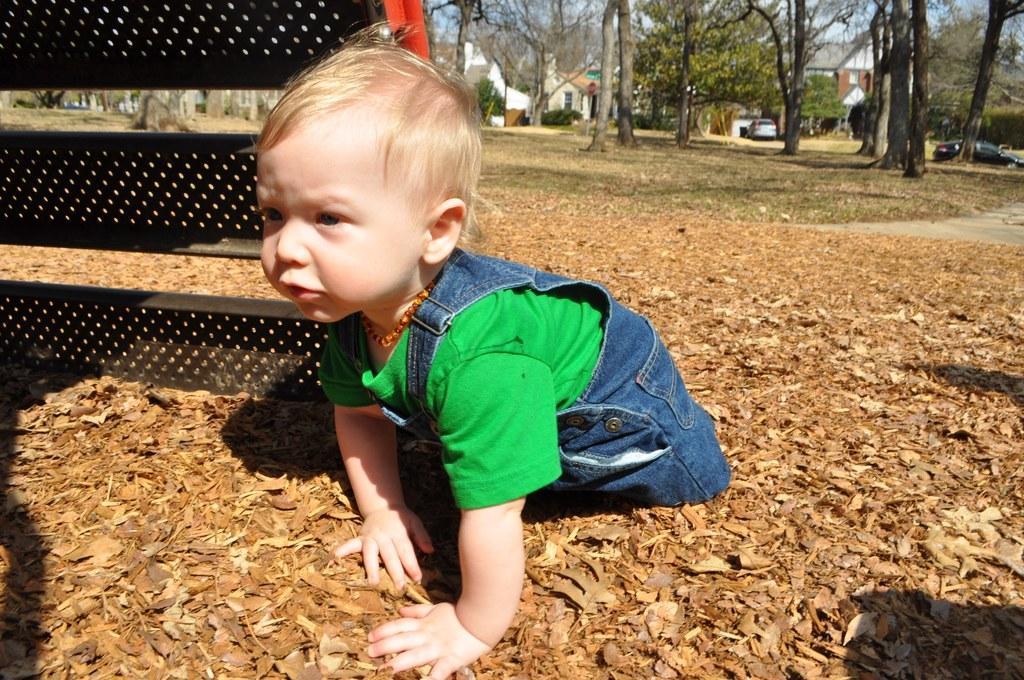In one or two sentences, can you explain what this image depicts? In this picture there is a boy and there is an object. At the back there are buildings and trees and vehicles. At the top there is sky. At the bottom there is a pavement and there are dried leaves. 